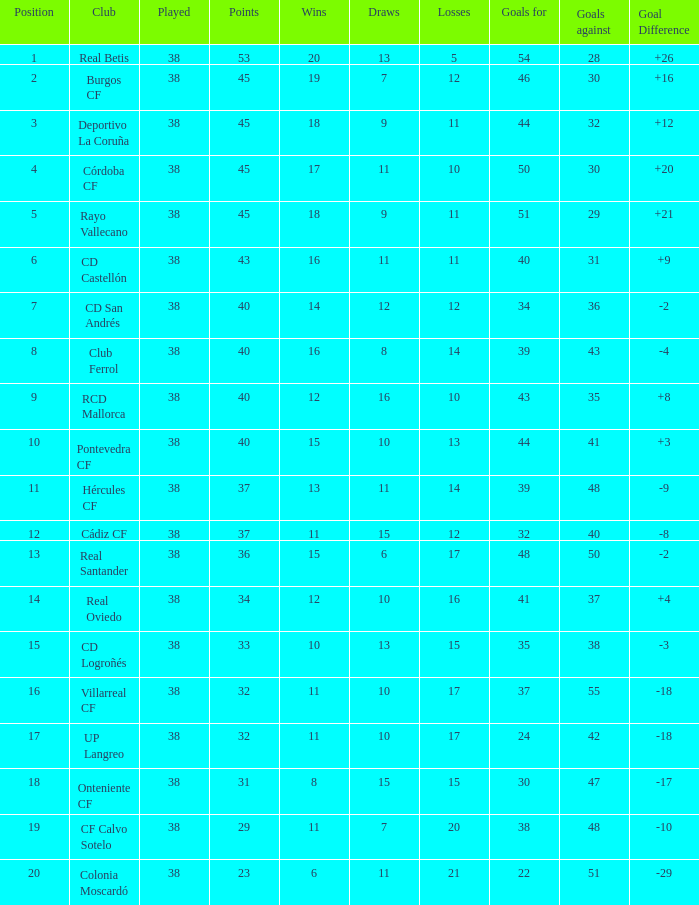What is the mean draws, when goal difference exceeds -3, when goals against equals 30, and when points surpass 45? None. 